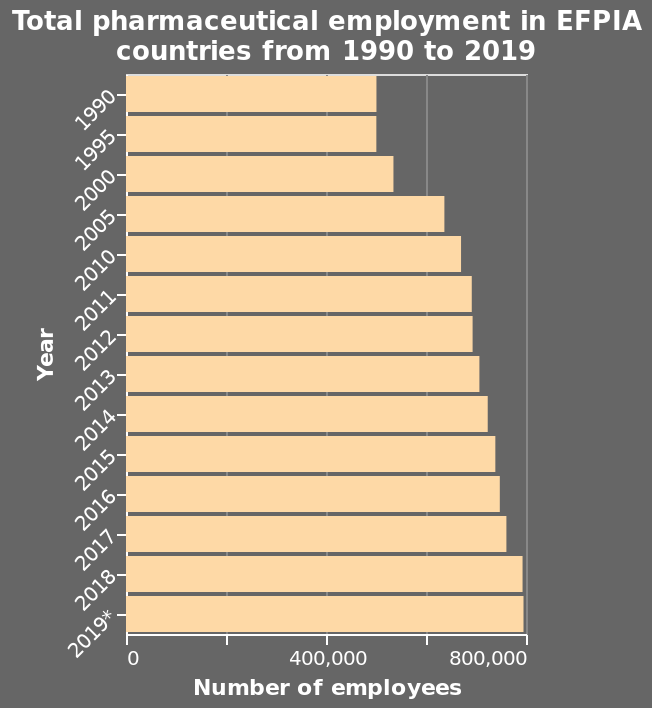<image>
What was the approximate number of pharmaceutical employees in 2005? The approximate number of pharmaceutical employees in 2005 was just over 600,000. How much did the number of pharmaceutical employees increase from 2005 to 2019? The number of pharmaceutical employees increased from just over 600,000 in 2005 to just under 800,000 in 2019. What does the y-axis represent in this plot?  The y-axis represents the year. 